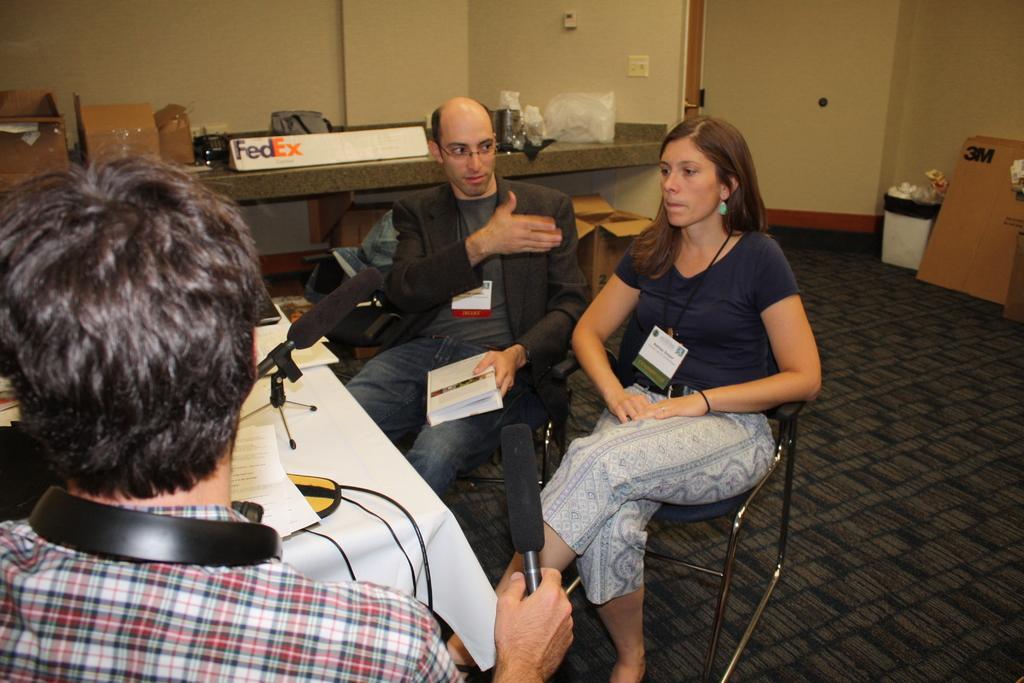Describe this image in one or two sentences. In this picture we can see man and woman sitting on chair here man is holding mic in his hand and in front of them there is table and on table we can see paper, wired, mic stand, book, boxes, plastic covers and in background we can see wall, bin. 